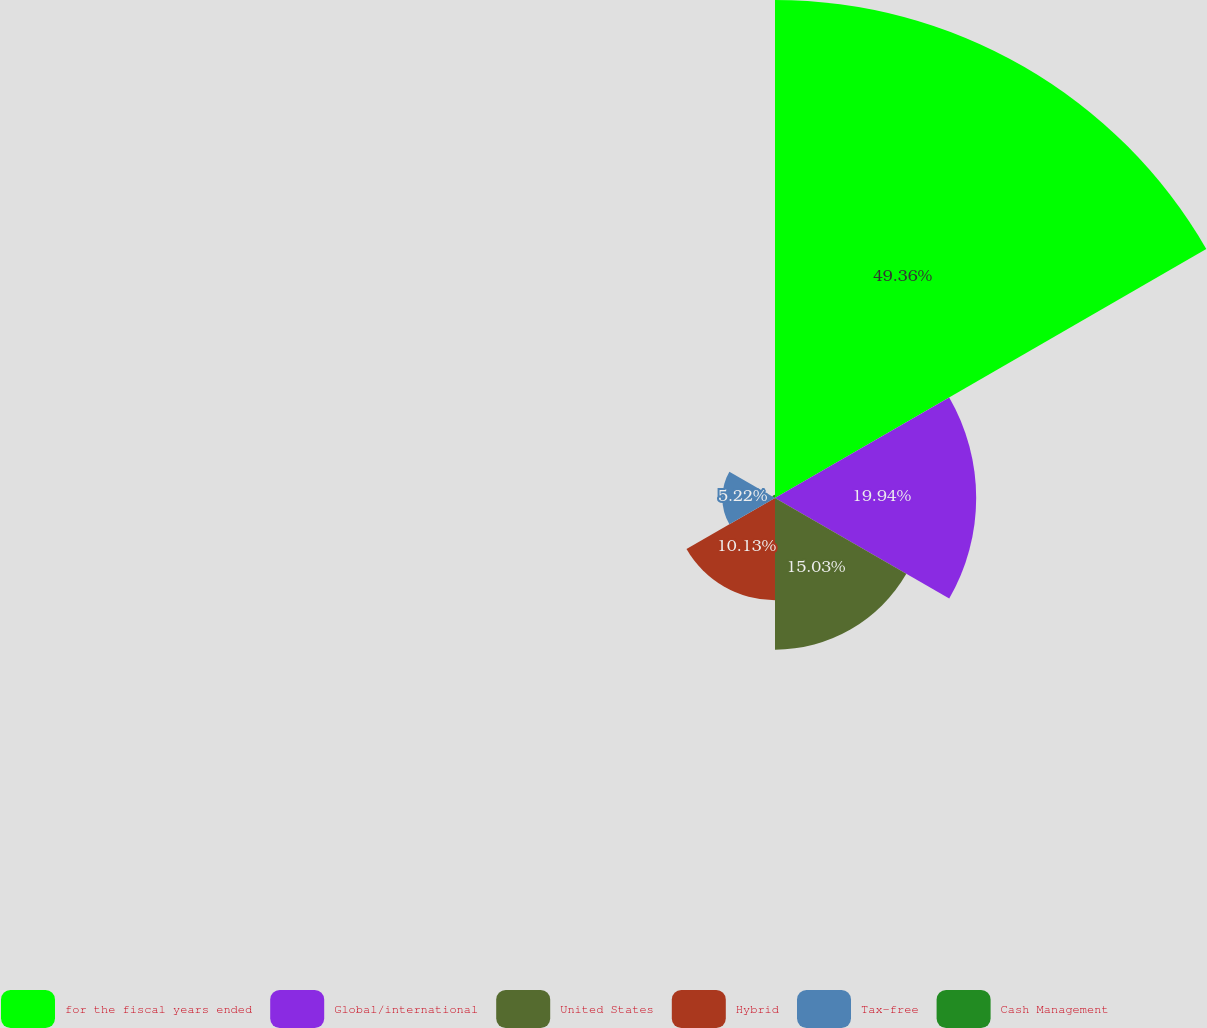<chart> <loc_0><loc_0><loc_500><loc_500><pie_chart><fcel>for the fiscal years ended<fcel>Global/international<fcel>United States<fcel>Hybrid<fcel>Tax-free<fcel>Cash Management<nl><fcel>49.36%<fcel>19.94%<fcel>15.03%<fcel>10.13%<fcel>5.22%<fcel>0.32%<nl></chart> 